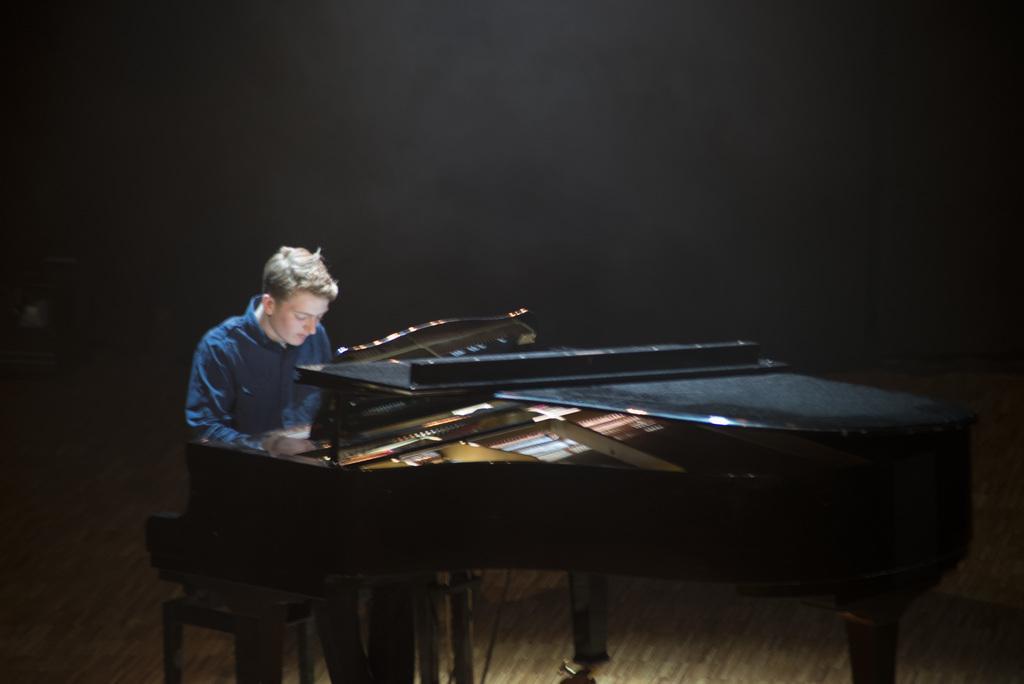Can you describe this image briefly? In this image, In the right side there is a black color piano ,There is a person sitting on the chair and playing the piano, In the background there is a black color wall. 